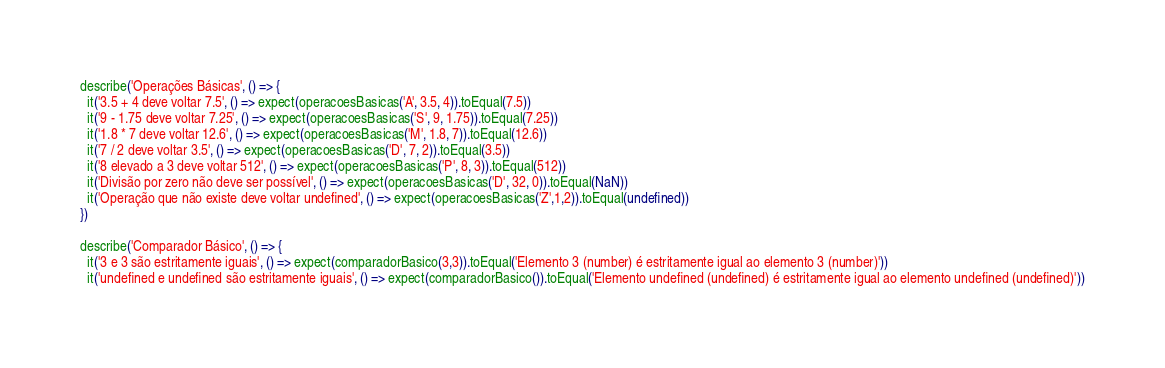<code> <loc_0><loc_0><loc_500><loc_500><_JavaScript_>describe('Operações Básicas', () => {
  it('3.5 + 4 deve voltar 7.5', () => expect(operacoesBasicas('A', 3.5, 4)).toEqual(7.5))
  it('9 - 1.75 deve voltar 7.25', () => expect(operacoesBasicas('S', 9, 1.75)).toEqual(7.25))
  it('1.8 * 7 deve voltar 12.6', () => expect(operacoesBasicas('M', 1.8, 7)).toEqual(12.6))
  it('7 / 2 deve voltar 3.5', () => expect(operacoesBasicas('D', 7, 2)).toEqual(3.5))
  it('8 elevado a 3 deve voltar 512', () => expect(operacoesBasicas('P', 8, 3)).toEqual(512))
  it('Divisão por zero não deve ser possível', () => expect(operacoesBasicas('D', 32, 0)).toEqual(NaN))
  it('Operação que não existe deve voltar undefined', () => expect(operacoesBasicas('Z',1,2)).toEqual(undefined))
})

describe('Comparador Básico', () => {
  it('3 e 3 são estritamente iguais', () => expect(comparadorBasico(3,3)).toEqual('Elemento 3 (number) é estritamente igual ao elemento 3 (number)'))
  it('undefined e undefined são estritamente iguais', () => expect(comparadorBasico()).toEqual('Elemento undefined (undefined) é estritamente igual ao elemento undefined (undefined)'))</code> 